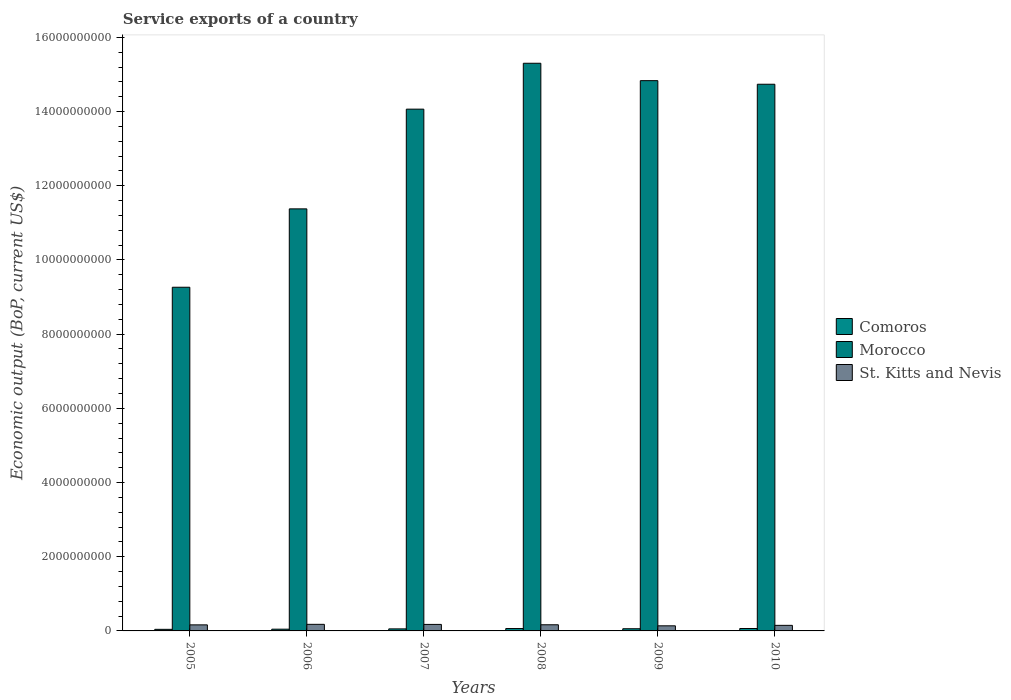Are the number of bars per tick equal to the number of legend labels?
Offer a terse response. Yes. Are the number of bars on each tick of the X-axis equal?
Make the answer very short. Yes. How many bars are there on the 1st tick from the left?
Your answer should be compact. 3. How many bars are there on the 3rd tick from the right?
Offer a very short reply. 3. What is the service exports in St. Kitts and Nevis in 2006?
Give a very brief answer. 1.77e+08. Across all years, what is the maximum service exports in St. Kitts and Nevis?
Make the answer very short. 1.77e+08. Across all years, what is the minimum service exports in Comoros?
Provide a short and direct response. 4.27e+07. In which year was the service exports in Comoros maximum?
Your answer should be very brief. 2010. What is the total service exports in Comoros in the graph?
Your answer should be compact. 3.33e+08. What is the difference between the service exports in St. Kitts and Nevis in 2005 and that in 2007?
Provide a succinct answer. -1.23e+07. What is the difference between the service exports in St. Kitts and Nevis in 2008 and the service exports in Morocco in 2009?
Offer a very short reply. -1.47e+1. What is the average service exports in Morocco per year?
Ensure brevity in your answer.  1.33e+1. In the year 2005, what is the difference between the service exports in Comoros and service exports in St. Kitts and Nevis?
Make the answer very short. -1.20e+08. In how many years, is the service exports in Comoros greater than 6400000000 US$?
Keep it short and to the point. 0. What is the ratio of the service exports in Morocco in 2005 to that in 2008?
Keep it short and to the point. 0.61. Is the service exports in Comoros in 2008 less than that in 2010?
Provide a succinct answer. Yes. What is the difference between the highest and the second highest service exports in St. Kitts and Nevis?
Provide a short and direct response. 2.00e+06. What is the difference between the highest and the lowest service exports in Morocco?
Provide a short and direct response. 6.04e+09. In how many years, is the service exports in Morocco greater than the average service exports in Morocco taken over all years?
Ensure brevity in your answer.  4. What does the 3rd bar from the left in 2007 represents?
Give a very brief answer. St. Kitts and Nevis. What does the 1st bar from the right in 2010 represents?
Give a very brief answer. St. Kitts and Nevis. Is it the case that in every year, the sum of the service exports in Comoros and service exports in St. Kitts and Nevis is greater than the service exports in Morocco?
Provide a short and direct response. No. Are all the bars in the graph horizontal?
Provide a succinct answer. No. What is the difference between two consecutive major ticks on the Y-axis?
Provide a succinct answer. 2.00e+09. Are the values on the major ticks of Y-axis written in scientific E-notation?
Make the answer very short. No. Where does the legend appear in the graph?
Your answer should be compact. Center right. What is the title of the graph?
Offer a terse response. Service exports of a country. Does "Vanuatu" appear as one of the legend labels in the graph?
Provide a succinct answer. No. What is the label or title of the X-axis?
Offer a very short reply. Years. What is the label or title of the Y-axis?
Your answer should be compact. Economic output (BoP, current US$). What is the Economic output (BoP, current US$) of Comoros in 2005?
Your response must be concise. 4.27e+07. What is the Economic output (BoP, current US$) of Morocco in 2005?
Make the answer very short. 9.26e+09. What is the Economic output (BoP, current US$) of St. Kitts and Nevis in 2005?
Your answer should be very brief. 1.63e+08. What is the Economic output (BoP, current US$) of Comoros in 2006?
Give a very brief answer. 4.68e+07. What is the Economic output (BoP, current US$) in Morocco in 2006?
Offer a very short reply. 1.14e+1. What is the Economic output (BoP, current US$) in St. Kitts and Nevis in 2006?
Provide a short and direct response. 1.77e+08. What is the Economic output (BoP, current US$) in Comoros in 2007?
Keep it short and to the point. 5.50e+07. What is the Economic output (BoP, current US$) in Morocco in 2007?
Your response must be concise. 1.41e+1. What is the Economic output (BoP, current US$) of St. Kitts and Nevis in 2007?
Give a very brief answer. 1.75e+08. What is the Economic output (BoP, current US$) of Comoros in 2008?
Ensure brevity in your answer.  6.43e+07. What is the Economic output (BoP, current US$) of Morocco in 2008?
Keep it short and to the point. 1.53e+1. What is the Economic output (BoP, current US$) in St. Kitts and Nevis in 2008?
Provide a succinct answer. 1.66e+08. What is the Economic output (BoP, current US$) of Comoros in 2009?
Make the answer very short. 5.88e+07. What is the Economic output (BoP, current US$) of Morocco in 2009?
Give a very brief answer. 1.48e+1. What is the Economic output (BoP, current US$) in St. Kitts and Nevis in 2009?
Ensure brevity in your answer.  1.37e+08. What is the Economic output (BoP, current US$) in Comoros in 2010?
Offer a very short reply. 6.49e+07. What is the Economic output (BoP, current US$) in Morocco in 2010?
Give a very brief answer. 1.47e+1. What is the Economic output (BoP, current US$) in St. Kitts and Nevis in 2010?
Your response must be concise. 1.50e+08. Across all years, what is the maximum Economic output (BoP, current US$) of Comoros?
Offer a very short reply. 6.49e+07. Across all years, what is the maximum Economic output (BoP, current US$) of Morocco?
Provide a succinct answer. 1.53e+1. Across all years, what is the maximum Economic output (BoP, current US$) in St. Kitts and Nevis?
Keep it short and to the point. 1.77e+08. Across all years, what is the minimum Economic output (BoP, current US$) of Comoros?
Offer a very short reply. 4.27e+07. Across all years, what is the minimum Economic output (BoP, current US$) of Morocco?
Give a very brief answer. 9.26e+09. Across all years, what is the minimum Economic output (BoP, current US$) of St. Kitts and Nevis?
Offer a very short reply. 1.37e+08. What is the total Economic output (BoP, current US$) in Comoros in the graph?
Your answer should be compact. 3.33e+08. What is the total Economic output (BoP, current US$) in Morocco in the graph?
Provide a short and direct response. 7.96e+1. What is the total Economic output (BoP, current US$) of St. Kitts and Nevis in the graph?
Keep it short and to the point. 9.70e+08. What is the difference between the Economic output (BoP, current US$) in Comoros in 2005 and that in 2006?
Your answer should be very brief. -4.09e+06. What is the difference between the Economic output (BoP, current US$) of Morocco in 2005 and that in 2006?
Keep it short and to the point. -2.11e+09. What is the difference between the Economic output (BoP, current US$) of St. Kitts and Nevis in 2005 and that in 2006?
Your answer should be very brief. -1.43e+07. What is the difference between the Economic output (BoP, current US$) of Comoros in 2005 and that in 2007?
Offer a terse response. -1.23e+07. What is the difference between the Economic output (BoP, current US$) in Morocco in 2005 and that in 2007?
Keep it short and to the point. -4.80e+09. What is the difference between the Economic output (BoP, current US$) of St. Kitts and Nevis in 2005 and that in 2007?
Provide a short and direct response. -1.23e+07. What is the difference between the Economic output (BoP, current US$) in Comoros in 2005 and that in 2008?
Give a very brief answer. -2.16e+07. What is the difference between the Economic output (BoP, current US$) in Morocco in 2005 and that in 2008?
Offer a very short reply. -6.04e+09. What is the difference between the Economic output (BoP, current US$) in St. Kitts and Nevis in 2005 and that in 2008?
Make the answer very short. -2.60e+06. What is the difference between the Economic output (BoP, current US$) in Comoros in 2005 and that in 2009?
Your answer should be compact. -1.61e+07. What is the difference between the Economic output (BoP, current US$) in Morocco in 2005 and that in 2009?
Offer a terse response. -5.57e+09. What is the difference between the Economic output (BoP, current US$) of St. Kitts and Nevis in 2005 and that in 2009?
Offer a terse response. 2.59e+07. What is the difference between the Economic output (BoP, current US$) in Comoros in 2005 and that in 2010?
Provide a short and direct response. -2.21e+07. What is the difference between the Economic output (BoP, current US$) of Morocco in 2005 and that in 2010?
Offer a very short reply. -5.47e+09. What is the difference between the Economic output (BoP, current US$) in St. Kitts and Nevis in 2005 and that in 2010?
Keep it short and to the point. 1.30e+07. What is the difference between the Economic output (BoP, current US$) of Comoros in 2006 and that in 2007?
Give a very brief answer. -8.18e+06. What is the difference between the Economic output (BoP, current US$) of Morocco in 2006 and that in 2007?
Ensure brevity in your answer.  -2.69e+09. What is the difference between the Economic output (BoP, current US$) of St. Kitts and Nevis in 2006 and that in 2007?
Give a very brief answer. 2.00e+06. What is the difference between the Economic output (BoP, current US$) in Comoros in 2006 and that in 2008?
Your answer should be compact. -1.75e+07. What is the difference between the Economic output (BoP, current US$) in Morocco in 2006 and that in 2008?
Provide a succinct answer. -3.92e+09. What is the difference between the Economic output (BoP, current US$) in St. Kitts and Nevis in 2006 and that in 2008?
Offer a very short reply. 1.17e+07. What is the difference between the Economic output (BoP, current US$) of Comoros in 2006 and that in 2009?
Your answer should be compact. -1.20e+07. What is the difference between the Economic output (BoP, current US$) of Morocco in 2006 and that in 2009?
Make the answer very short. -3.46e+09. What is the difference between the Economic output (BoP, current US$) in St. Kitts and Nevis in 2006 and that in 2009?
Offer a very short reply. 4.02e+07. What is the difference between the Economic output (BoP, current US$) of Comoros in 2006 and that in 2010?
Keep it short and to the point. -1.80e+07. What is the difference between the Economic output (BoP, current US$) in Morocco in 2006 and that in 2010?
Your response must be concise. -3.36e+09. What is the difference between the Economic output (BoP, current US$) in St. Kitts and Nevis in 2006 and that in 2010?
Keep it short and to the point. 2.73e+07. What is the difference between the Economic output (BoP, current US$) in Comoros in 2007 and that in 2008?
Offer a very short reply. -9.32e+06. What is the difference between the Economic output (BoP, current US$) of Morocco in 2007 and that in 2008?
Provide a succinct answer. -1.24e+09. What is the difference between the Economic output (BoP, current US$) of St. Kitts and Nevis in 2007 and that in 2008?
Keep it short and to the point. 9.67e+06. What is the difference between the Economic output (BoP, current US$) of Comoros in 2007 and that in 2009?
Ensure brevity in your answer.  -3.84e+06. What is the difference between the Economic output (BoP, current US$) in Morocco in 2007 and that in 2009?
Your answer should be compact. -7.68e+08. What is the difference between the Economic output (BoP, current US$) in St. Kitts and Nevis in 2007 and that in 2009?
Provide a succinct answer. 3.82e+07. What is the difference between the Economic output (BoP, current US$) of Comoros in 2007 and that in 2010?
Your answer should be very brief. -9.87e+06. What is the difference between the Economic output (BoP, current US$) of Morocco in 2007 and that in 2010?
Provide a short and direct response. -6.71e+08. What is the difference between the Economic output (BoP, current US$) in St. Kitts and Nevis in 2007 and that in 2010?
Your answer should be very brief. 2.53e+07. What is the difference between the Economic output (BoP, current US$) in Comoros in 2008 and that in 2009?
Provide a succinct answer. 5.49e+06. What is the difference between the Economic output (BoP, current US$) of Morocco in 2008 and that in 2009?
Your answer should be very brief. 4.69e+08. What is the difference between the Economic output (BoP, current US$) in St. Kitts and Nevis in 2008 and that in 2009?
Give a very brief answer. 2.85e+07. What is the difference between the Economic output (BoP, current US$) in Comoros in 2008 and that in 2010?
Offer a terse response. -5.41e+05. What is the difference between the Economic output (BoP, current US$) of Morocco in 2008 and that in 2010?
Keep it short and to the point. 5.66e+08. What is the difference between the Economic output (BoP, current US$) in St. Kitts and Nevis in 2008 and that in 2010?
Your response must be concise. 1.56e+07. What is the difference between the Economic output (BoP, current US$) in Comoros in 2009 and that in 2010?
Your answer should be very brief. -6.03e+06. What is the difference between the Economic output (BoP, current US$) in Morocco in 2009 and that in 2010?
Offer a very short reply. 9.66e+07. What is the difference between the Economic output (BoP, current US$) of St. Kitts and Nevis in 2009 and that in 2010?
Your answer should be very brief. -1.29e+07. What is the difference between the Economic output (BoP, current US$) in Comoros in 2005 and the Economic output (BoP, current US$) in Morocco in 2006?
Make the answer very short. -1.13e+1. What is the difference between the Economic output (BoP, current US$) in Comoros in 2005 and the Economic output (BoP, current US$) in St. Kitts and Nevis in 2006?
Your answer should be very brief. -1.35e+08. What is the difference between the Economic output (BoP, current US$) of Morocco in 2005 and the Economic output (BoP, current US$) of St. Kitts and Nevis in 2006?
Ensure brevity in your answer.  9.09e+09. What is the difference between the Economic output (BoP, current US$) of Comoros in 2005 and the Economic output (BoP, current US$) of Morocco in 2007?
Provide a succinct answer. -1.40e+1. What is the difference between the Economic output (BoP, current US$) of Comoros in 2005 and the Economic output (BoP, current US$) of St. Kitts and Nevis in 2007?
Provide a succinct answer. -1.33e+08. What is the difference between the Economic output (BoP, current US$) of Morocco in 2005 and the Economic output (BoP, current US$) of St. Kitts and Nevis in 2007?
Give a very brief answer. 9.09e+09. What is the difference between the Economic output (BoP, current US$) in Comoros in 2005 and the Economic output (BoP, current US$) in Morocco in 2008?
Your answer should be compact. -1.53e+1. What is the difference between the Economic output (BoP, current US$) of Comoros in 2005 and the Economic output (BoP, current US$) of St. Kitts and Nevis in 2008?
Provide a short and direct response. -1.23e+08. What is the difference between the Economic output (BoP, current US$) in Morocco in 2005 and the Economic output (BoP, current US$) in St. Kitts and Nevis in 2008?
Make the answer very short. 9.10e+09. What is the difference between the Economic output (BoP, current US$) in Comoros in 2005 and the Economic output (BoP, current US$) in Morocco in 2009?
Your answer should be compact. -1.48e+1. What is the difference between the Economic output (BoP, current US$) in Comoros in 2005 and the Economic output (BoP, current US$) in St. Kitts and Nevis in 2009?
Keep it short and to the point. -9.46e+07. What is the difference between the Economic output (BoP, current US$) in Morocco in 2005 and the Economic output (BoP, current US$) in St. Kitts and Nevis in 2009?
Ensure brevity in your answer.  9.13e+09. What is the difference between the Economic output (BoP, current US$) in Comoros in 2005 and the Economic output (BoP, current US$) in Morocco in 2010?
Provide a short and direct response. -1.47e+1. What is the difference between the Economic output (BoP, current US$) of Comoros in 2005 and the Economic output (BoP, current US$) of St. Kitts and Nevis in 2010?
Provide a short and direct response. -1.08e+08. What is the difference between the Economic output (BoP, current US$) in Morocco in 2005 and the Economic output (BoP, current US$) in St. Kitts and Nevis in 2010?
Make the answer very short. 9.11e+09. What is the difference between the Economic output (BoP, current US$) of Comoros in 2006 and the Economic output (BoP, current US$) of Morocco in 2007?
Offer a terse response. -1.40e+1. What is the difference between the Economic output (BoP, current US$) in Comoros in 2006 and the Economic output (BoP, current US$) in St. Kitts and Nevis in 2007?
Provide a succinct answer. -1.29e+08. What is the difference between the Economic output (BoP, current US$) of Morocco in 2006 and the Economic output (BoP, current US$) of St. Kitts and Nevis in 2007?
Offer a very short reply. 1.12e+1. What is the difference between the Economic output (BoP, current US$) of Comoros in 2006 and the Economic output (BoP, current US$) of Morocco in 2008?
Keep it short and to the point. -1.53e+1. What is the difference between the Economic output (BoP, current US$) in Comoros in 2006 and the Economic output (BoP, current US$) in St. Kitts and Nevis in 2008?
Give a very brief answer. -1.19e+08. What is the difference between the Economic output (BoP, current US$) of Morocco in 2006 and the Economic output (BoP, current US$) of St. Kitts and Nevis in 2008?
Keep it short and to the point. 1.12e+1. What is the difference between the Economic output (BoP, current US$) in Comoros in 2006 and the Economic output (BoP, current US$) in Morocco in 2009?
Ensure brevity in your answer.  -1.48e+1. What is the difference between the Economic output (BoP, current US$) of Comoros in 2006 and the Economic output (BoP, current US$) of St. Kitts and Nevis in 2009?
Provide a succinct answer. -9.05e+07. What is the difference between the Economic output (BoP, current US$) of Morocco in 2006 and the Economic output (BoP, current US$) of St. Kitts and Nevis in 2009?
Your answer should be very brief. 1.12e+1. What is the difference between the Economic output (BoP, current US$) of Comoros in 2006 and the Economic output (BoP, current US$) of Morocco in 2010?
Make the answer very short. -1.47e+1. What is the difference between the Economic output (BoP, current US$) of Comoros in 2006 and the Economic output (BoP, current US$) of St. Kitts and Nevis in 2010?
Provide a succinct answer. -1.03e+08. What is the difference between the Economic output (BoP, current US$) of Morocco in 2006 and the Economic output (BoP, current US$) of St. Kitts and Nevis in 2010?
Your answer should be compact. 1.12e+1. What is the difference between the Economic output (BoP, current US$) of Comoros in 2007 and the Economic output (BoP, current US$) of Morocco in 2008?
Keep it short and to the point. -1.52e+1. What is the difference between the Economic output (BoP, current US$) of Comoros in 2007 and the Economic output (BoP, current US$) of St. Kitts and Nevis in 2008?
Keep it short and to the point. -1.11e+08. What is the difference between the Economic output (BoP, current US$) in Morocco in 2007 and the Economic output (BoP, current US$) in St. Kitts and Nevis in 2008?
Keep it short and to the point. 1.39e+1. What is the difference between the Economic output (BoP, current US$) of Comoros in 2007 and the Economic output (BoP, current US$) of Morocco in 2009?
Provide a short and direct response. -1.48e+1. What is the difference between the Economic output (BoP, current US$) of Comoros in 2007 and the Economic output (BoP, current US$) of St. Kitts and Nevis in 2009?
Offer a terse response. -8.23e+07. What is the difference between the Economic output (BoP, current US$) of Morocco in 2007 and the Economic output (BoP, current US$) of St. Kitts and Nevis in 2009?
Provide a short and direct response. 1.39e+1. What is the difference between the Economic output (BoP, current US$) in Comoros in 2007 and the Economic output (BoP, current US$) in Morocco in 2010?
Your answer should be very brief. -1.47e+1. What is the difference between the Economic output (BoP, current US$) of Comoros in 2007 and the Economic output (BoP, current US$) of St. Kitts and Nevis in 2010?
Ensure brevity in your answer.  -9.52e+07. What is the difference between the Economic output (BoP, current US$) in Morocco in 2007 and the Economic output (BoP, current US$) in St. Kitts and Nevis in 2010?
Keep it short and to the point. 1.39e+1. What is the difference between the Economic output (BoP, current US$) of Comoros in 2008 and the Economic output (BoP, current US$) of Morocco in 2009?
Offer a very short reply. -1.48e+1. What is the difference between the Economic output (BoP, current US$) in Comoros in 2008 and the Economic output (BoP, current US$) in St. Kitts and Nevis in 2009?
Your answer should be very brief. -7.30e+07. What is the difference between the Economic output (BoP, current US$) of Morocco in 2008 and the Economic output (BoP, current US$) of St. Kitts and Nevis in 2009?
Provide a succinct answer. 1.52e+1. What is the difference between the Economic output (BoP, current US$) of Comoros in 2008 and the Economic output (BoP, current US$) of Morocco in 2010?
Provide a succinct answer. -1.47e+1. What is the difference between the Economic output (BoP, current US$) of Comoros in 2008 and the Economic output (BoP, current US$) of St. Kitts and Nevis in 2010?
Your response must be concise. -8.59e+07. What is the difference between the Economic output (BoP, current US$) of Morocco in 2008 and the Economic output (BoP, current US$) of St. Kitts and Nevis in 2010?
Ensure brevity in your answer.  1.52e+1. What is the difference between the Economic output (BoP, current US$) of Comoros in 2009 and the Economic output (BoP, current US$) of Morocco in 2010?
Offer a very short reply. -1.47e+1. What is the difference between the Economic output (BoP, current US$) of Comoros in 2009 and the Economic output (BoP, current US$) of St. Kitts and Nevis in 2010?
Give a very brief answer. -9.14e+07. What is the difference between the Economic output (BoP, current US$) in Morocco in 2009 and the Economic output (BoP, current US$) in St. Kitts and Nevis in 2010?
Ensure brevity in your answer.  1.47e+1. What is the average Economic output (BoP, current US$) in Comoros per year?
Ensure brevity in your answer.  5.54e+07. What is the average Economic output (BoP, current US$) of Morocco per year?
Provide a succinct answer. 1.33e+1. What is the average Economic output (BoP, current US$) in St. Kitts and Nevis per year?
Your response must be concise. 1.62e+08. In the year 2005, what is the difference between the Economic output (BoP, current US$) in Comoros and Economic output (BoP, current US$) in Morocco?
Your answer should be very brief. -9.22e+09. In the year 2005, what is the difference between the Economic output (BoP, current US$) of Comoros and Economic output (BoP, current US$) of St. Kitts and Nevis?
Your response must be concise. -1.20e+08. In the year 2005, what is the difference between the Economic output (BoP, current US$) of Morocco and Economic output (BoP, current US$) of St. Kitts and Nevis?
Ensure brevity in your answer.  9.10e+09. In the year 2006, what is the difference between the Economic output (BoP, current US$) of Comoros and Economic output (BoP, current US$) of Morocco?
Ensure brevity in your answer.  -1.13e+1. In the year 2006, what is the difference between the Economic output (BoP, current US$) in Comoros and Economic output (BoP, current US$) in St. Kitts and Nevis?
Offer a terse response. -1.31e+08. In the year 2006, what is the difference between the Economic output (BoP, current US$) in Morocco and Economic output (BoP, current US$) in St. Kitts and Nevis?
Make the answer very short. 1.12e+1. In the year 2007, what is the difference between the Economic output (BoP, current US$) in Comoros and Economic output (BoP, current US$) in Morocco?
Your answer should be compact. -1.40e+1. In the year 2007, what is the difference between the Economic output (BoP, current US$) in Comoros and Economic output (BoP, current US$) in St. Kitts and Nevis?
Provide a short and direct response. -1.21e+08. In the year 2007, what is the difference between the Economic output (BoP, current US$) of Morocco and Economic output (BoP, current US$) of St. Kitts and Nevis?
Ensure brevity in your answer.  1.39e+1. In the year 2008, what is the difference between the Economic output (BoP, current US$) of Comoros and Economic output (BoP, current US$) of Morocco?
Ensure brevity in your answer.  -1.52e+1. In the year 2008, what is the difference between the Economic output (BoP, current US$) of Comoros and Economic output (BoP, current US$) of St. Kitts and Nevis?
Provide a succinct answer. -1.02e+08. In the year 2008, what is the difference between the Economic output (BoP, current US$) of Morocco and Economic output (BoP, current US$) of St. Kitts and Nevis?
Offer a very short reply. 1.51e+1. In the year 2009, what is the difference between the Economic output (BoP, current US$) in Comoros and Economic output (BoP, current US$) in Morocco?
Make the answer very short. -1.48e+1. In the year 2009, what is the difference between the Economic output (BoP, current US$) of Comoros and Economic output (BoP, current US$) of St. Kitts and Nevis?
Your answer should be compact. -7.85e+07. In the year 2009, what is the difference between the Economic output (BoP, current US$) in Morocco and Economic output (BoP, current US$) in St. Kitts and Nevis?
Give a very brief answer. 1.47e+1. In the year 2010, what is the difference between the Economic output (BoP, current US$) in Comoros and Economic output (BoP, current US$) in Morocco?
Keep it short and to the point. -1.47e+1. In the year 2010, what is the difference between the Economic output (BoP, current US$) in Comoros and Economic output (BoP, current US$) in St. Kitts and Nevis?
Ensure brevity in your answer.  -8.54e+07. In the year 2010, what is the difference between the Economic output (BoP, current US$) in Morocco and Economic output (BoP, current US$) in St. Kitts and Nevis?
Provide a short and direct response. 1.46e+1. What is the ratio of the Economic output (BoP, current US$) in Comoros in 2005 to that in 2006?
Offer a terse response. 0.91. What is the ratio of the Economic output (BoP, current US$) of Morocco in 2005 to that in 2006?
Your answer should be very brief. 0.81. What is the ratio of the Economic output (BoP, current US$) of St. Kitts and Nevis in 2005 to that in 2006?
Offer a terse response. 0.92. What is the ratio of the Economic output (BoP, current US$) of Comoros in 2005 to that in 2007?
Your answer should be very brief. 0.78. What is the ratio of the Economic output (BoP, current US$) in Morocco in 2005 to that in 2007?
Keep it short and to the point. 0.66. What is the ratio of the Economic output (BoP, current US$) of St. Kitts and Nevis in 2005 to that in 2007?
Your response must be concise. 0.93. What is the ratio of the Economic output (BoP, current US$) of Comoros in 2005 to that in 2008?
Your answer should be very brief. 0.66. What is the ratio of the Economic output (BoP, current US$) of Morocco in 2005 to that in 2008?
Your response must be concise. 0.61. What is the ratio of the Economic output (BoP, current US$) of St. Kitts and Nevis in 2005 to that in 2008?
Provide a succinct answer. 0.98. What is the ratio of the Economic output (BoP, current US$) of Comoros in 2005 to that in 2009?
Your answer should be very brief. 0.73. What is the ratio of the Economic output (BoP, current US$) of Morocco in 2005 to that in 2009?
Provide a short and direct response. 0.62. What is the ratio of the Economic output (BoP, current US$) of St. Kitts and Nevis in 2005 to that in 2009?
Provide a short and direct response. 1.19. What is the ratio of the Economic output (BoP, current US$) of Comoros in 2005 to that in 2010?
Provide a short and direct response. 0.66. What is the ratio of the Economic output (BoP, current US$) of Morocco in 2005 to that in 2010?
Make the answer very short. 0.63. What is the ratio of the Economic output (BoP, current US$) in St. Kitts and Nevis in 2005 to that in 2010?
Offer a terse response. 1.09. What is the ratio of the Economic output (BoP, current US$) in Comoros in 2006 to that in 2007?
Offer a terse response. 0.85. What is the ratio of the Economic output (BoP, current US$) of Morocco in 2006 to that in 2007?
Keep it short and to the point. 0.81. What is the ratio of the Economic output (BoP, current US$) of St. Kitts and Nevis in 2006 to that in 2007?
Provide a short and direct response. 1.01. What is the ratio of the Economic output (BoP, current US$) in Comoros in 2006 to that in 2008?
Your answer should be compact. 0.73. What is the ratio of the Economic output (BoP, current US$) of Morocco in 2006 to that in 2008?
Your answer should be very brief. 0.74. What is the ratio of the Economic output (BoP, current US$) in St. Kitts and Nevis in 2006 to that in 2008?
Make the answer very short. 1.07. What is the ratio of the Economic output (BoP, current US$) in Comoros in 2006 to that in 2009?
Your answer should be compact. 0.8. What is the ratio of the Economic output (BoP, current US$) in Morocco in 2006 to that in 2009?
Make the answer very short. 0.77. What is the ratio of the Economic output (BoP, current US$) in St. Kitts and Nevis in 2006 to that in 2009?
Provide a short and direct response. 1.29. What is the ratio of the Economic output (BoP, current US$) in Comoros in 2006 to that in 2010?
Your response must be concise. 0.72. What is the ratio of the Economic output (BoP, current US$) of Morocco in 2006 to that in 2010?
Your answer should be compact. 0.77. What is the ratio of the Economic output (BoP, current US$) in St. Kitts and Nevis in 2006 to that in 2010?
Offer a very short reply. 1.18. What is the ratio of the Economic output (BoP, current US$) of Comoros in 2007 to that in 2008?
Make the answer very short. 0.85. What is the ratio of the Economic output (BoP, current US$) of Morocco in 2007 to that in 2008?
Offer a terse response. 0.92. What is the ratio of the Economic output (BoP, current US$) of St. Kitts and Nevis in 2007 to that in 2008?
Keep it short and to the point. 1.06. What is the ratio of the Economic output (BoP, current US$) in Comoros in 2007 to that in 2009?
Your answer should be compact. 0.93. What is the ratio of the Economic output (BoP, current US$) in Morocco in 2007 to that in 2009?
Your answer should be compact. 0.95. What is the ratio of the Economic output (BoP, current US$) in St. Kitts and Nevis in 2007 to that in 2009?
Your answer should be very brief. 1.28. What is the ratio of the Economic output (BoP, current US$) in Comoros in 2007 to that in 2010?
Keep it short and to the point. 0.85. What is the ratio of the Economic output (BoP, current US$) in Morocco in 2007 to that in 2010?
Make the answer very short. 0.95. What is the ratio of the Economic output (BoP, current US$) of St. Kitts and Nevis in 2007 to that in 2010?
Provide a succinct answer. 1.17. What is the ratio of the Economic output (BoP, current US$) in Comoros in 2008 to that in 2009?
Ensure brevity in your answer.  1.09. What is the ratio of the Economic output (BoP, current US$) of Morocco in 2008 to that in 2009?
Keep it short and to the point. 1.03. What is the ratio of the Economic output (BoP, current US$) in St. Kitts and Nevis in 2008 to that in 2009?
Offer a very short reply. 1.21. What is the ratio of the Economic output (BoP, current US$) of Comoros in 2008 to that in 2010?
Give a very brief answer. 0.99. What is the ratio of the Economic output (BoP, current US$) in Morocco in 2008 to that in 2010?
Your response must be concise. 1.04. What is the ratio of the Economic output (BoP, current US$) of St. Kitts and Nevis in 2008 to that in 2010?
Offer a very short reply. 1.1. What is the ratio of the Economic output (BoP, current US$) in Comoros in 2009 to that in 2010?
Ensure brevity in your answer.  0.91. What is the ratio of the Economic output (BoP, current US$) in Morocco in 2009 to that in 2010?
Ensure brevity in your answer.  1.01. What is the ratio of the Economic output (BoP, current US$) in St. Kitts and Nevis in 2009 to that in 2010?
Ensure brevity in your answer.  0.91. What is the difference between the highest and the second highest Economic output (BoP, current US$) in Comoros?
Make the answer very short. 5.41e+05. What is the difference between the highest and the second highest Economic output (BoP, current US$) in Morocco?
Provide a succinct answer. 4.69e+08. What is the difference between the highest and the second highest Economic output (BoP, current US$) of St. Kitts and Nevis?
Offer a very short reply. 2.00e+06. What is the difference between the highest and the lowest Economic output (BoP, current US$) of Comoros?
Offer a terse response. 2.21e+07. What is the difference between the highest and the lowest Economic output (BoP, current US$) of Morocco?
Keep it short and to the point. 6.04e+09. What is the difference between the highest and the lowest Economic output (BoP, current US$) of St. Kitts and Nevis?
Your response must be concise. 4.02e+07. 